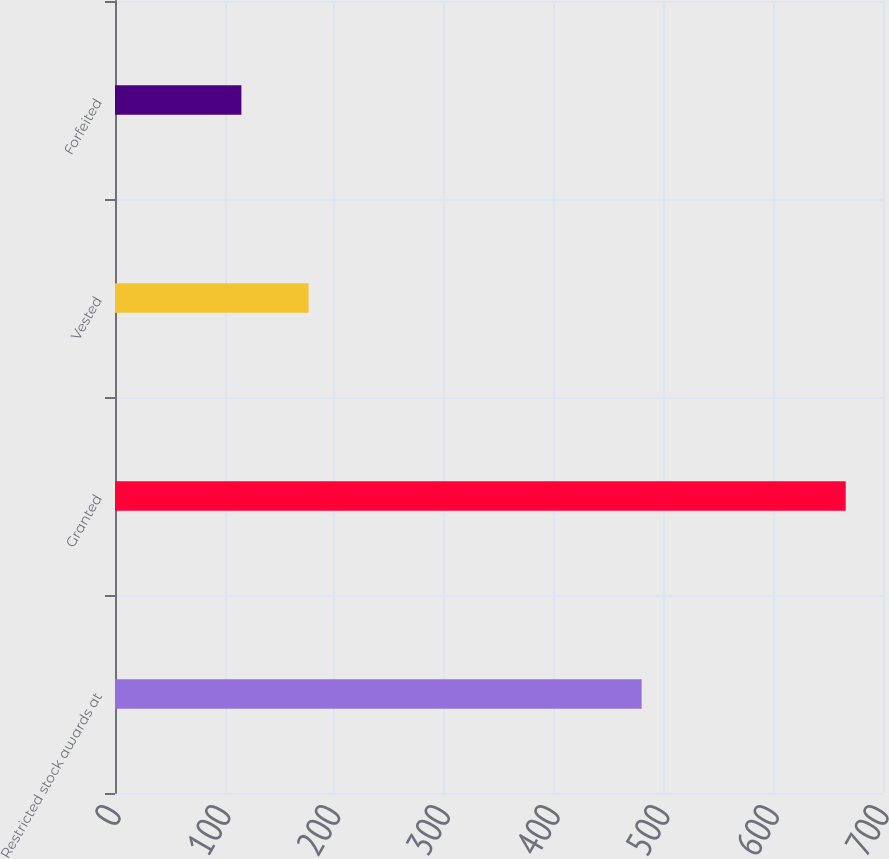Convert chart to OTSL. <chart><loc_0><loc_0><loc_500><loc_500><bar_chart><fcel>Restricted stock awards at<fcel>Granted<fcel>Vested<fcel>Forfeited<nl><fcel>480<fcel>666<fcel>176.4<fcel>115.2<nl></chart> 